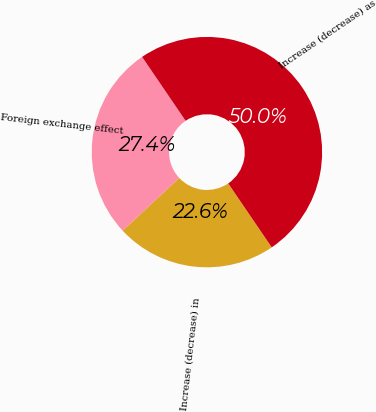Convert chart. <chart><loc_0><loc_0><loc_500><loc_500><pie_chart><fcel>Increase (decrease) in<fcel>Foreign exchange effect<fcel>Increase (decrease) as<nl><fcel>22.58%<fcel>27.42%<fcel>50.0%<nl></chart> 